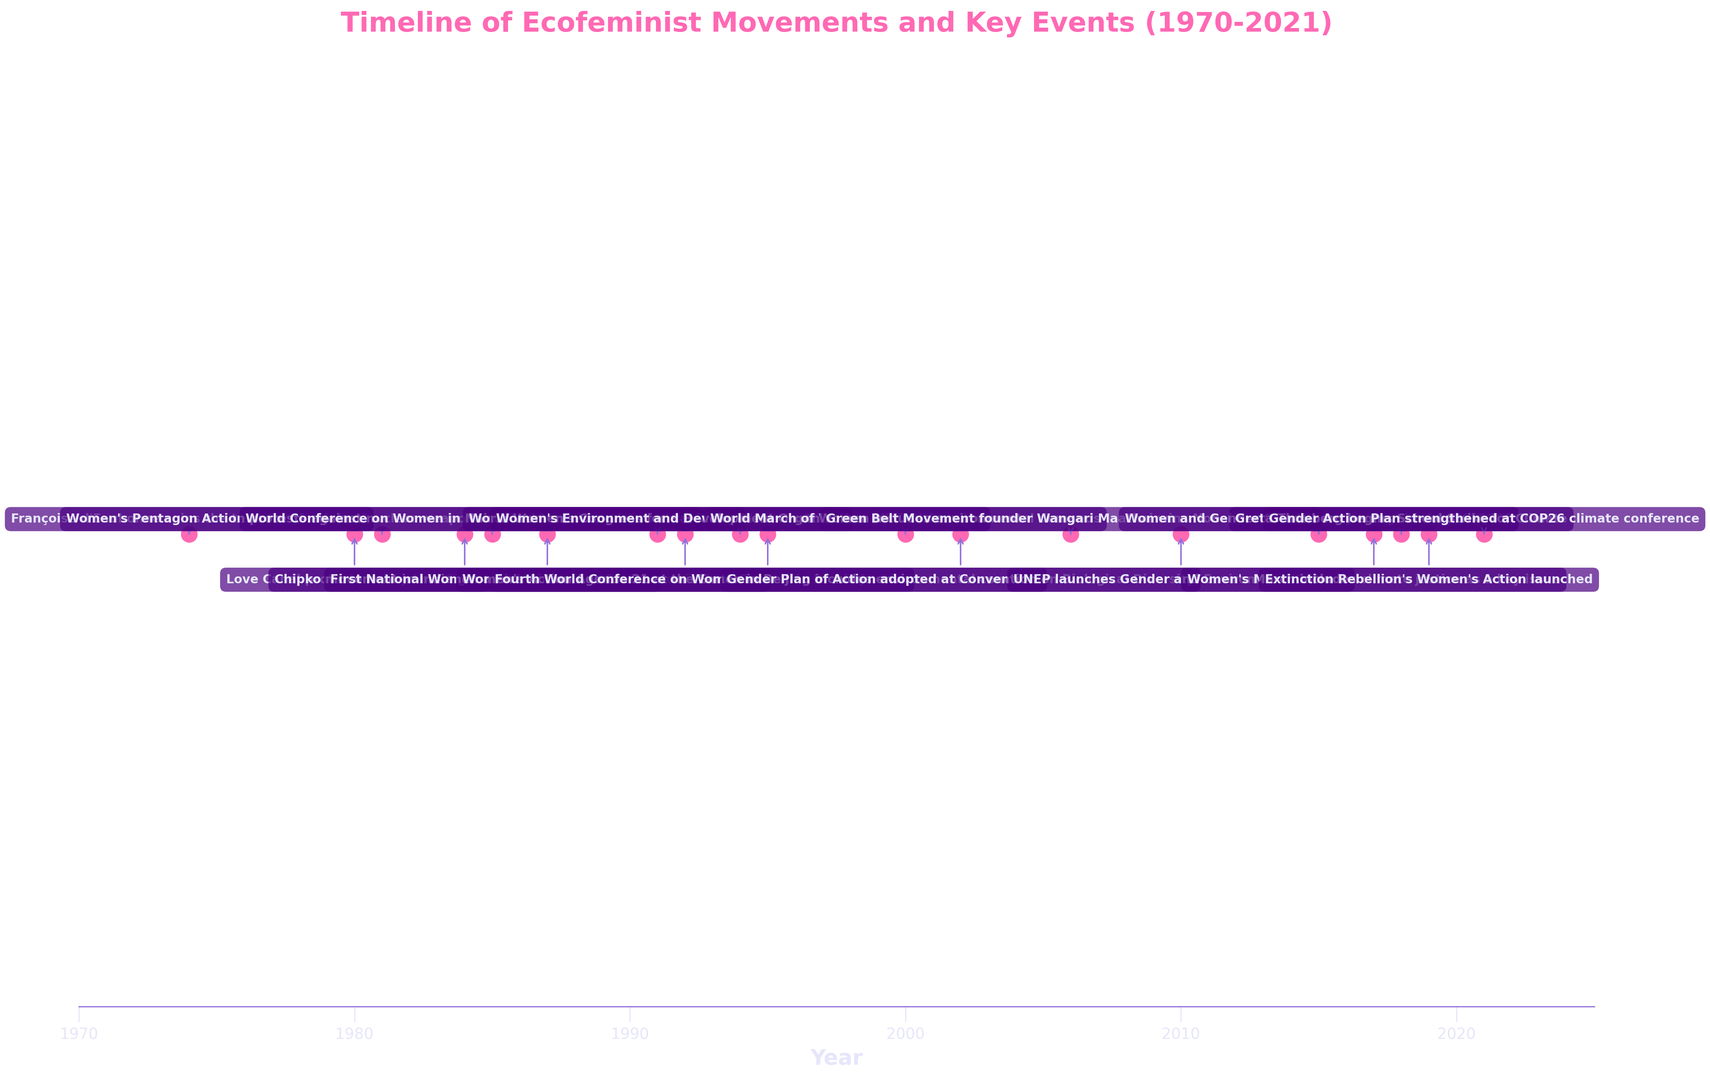Which year marked the founding of the Women's Environment and Development Organization (WEDO)? Locate the event for the founding of WEDO on the timeline. The label next to the event marker indicates "Women's Environment and Development Organization (WEDO) founded" in 1994.
Answer: 1994 Which event in the timeline occurred first? Identify the earliest year on the timeline. The first event labeled is "Françoise d'Eaubonne coins the term 'ecofeminism'" in 1974.
Answer: Françoise d'Eaubonne coins the term "ecofeminism" How many key events related to ecofeminist movements are depicted in the timeline between 1990 and 2000? Count the events that occurred between 1990 and 2000. There are World Women's Congress for a Healthy Planet (1991), Women's Action Agenda 21 at the Earth Summit (1992), Women's Environment and Development Organization (1994), and Fourth World Conference on Women (1995).
Answer: 4 What's the difference in years between the founding of the Green Belt Movement and the launch of the Gender Action Plan at COP26? Identify the years of the two events. The Green Belt Movement founder Wangari Maathai wins the Nobel Peace Prize in 2006, and the Gender Action Plan is strengthened in 2021. Calculate the difference (2021 - 2006).
Answer: 15 Which event closely follows the World Conference on Women in Nairobi in 1985? Find the World Conference on Women in Nairobi on the timeline and locate the event that follows it. The next event is the First National Women and Environment Conference in Australia in 1987.
Answer: First National Women and Environment Conference in Australia Which two events were directly related to the UN Framework Convention on Climate Change (UNFCCC)? Identify events mentioning the UNFCCC. These are "Women and Gender Constituency recognized by UNFCCC" in 2015 and "Gender Action Plan strengthened at COP26 climate conference" in 2021.
Answer: Women and Gender Constituency recognized by UNFCCC and Gender Action Plan strengthened at COP26 climate conference How many events are associated with conferences? Count the events mentioning conferences. These are: World Conference on Women in Nairobi (1985), First National Women and Environment Conference (1987), World Women's Congress for a Healthy Planet (1991), Fourth World Conference on Women (1995), and Convention on Biological Diversity (2002).
Answer: 5 Compare the number of events in the 1980s to the number in the 1990s. Which decade had more events? Count the events for each decade. The 1980s have 4 events: 1980, 1981, 1984, and 1985. The 1990s have 5 events: 1991, 1992, 1994, 1995, and 2000. Thus, the 1990s had more events.
Answer: The 1990s Which event marked the introduction of ecofeminist concerns into a global environmental summit? Find the first event mentioning inclusion in a global summit. "Women's Action Agenda 21 at the Earth Summit" in 1992 fits this description.
Answer: Women's Action Agenda 21 at the Earth Summit 